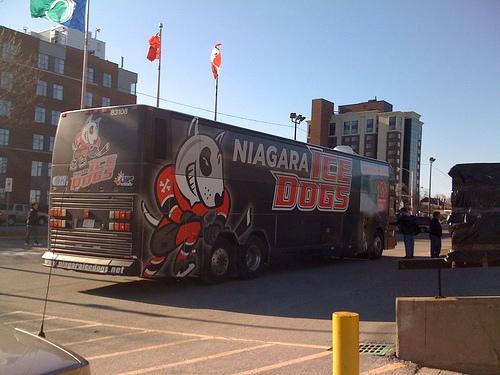What color is this bus?
Keep it brief. Black. How many flags are in the background?
Short answer required. 3. Is there a real dog in the photo?
Short answer required. No. 